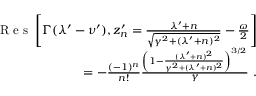Convert formula to latex. <formula><loc_0><loc_0><loc_500><loc_500>\begin{array} { r } { R e s \left [ \Gamma ( \lambda ^ { \prime } - \nu ^ { \prime } ) , z _ { n } ^ { \prime } = \frac { \lambda ^ { \prime } + n } { \sqrt { \gamma ^ { 2 } + ( \lambda ^ { \prime } + n ) ^ { 2 } } } - \frac { \omega } { 2 } \right ] } \\ { = - \frac { ( - 1 ) ^ { n } } { n ! } \frac { \left ( 1 - \frac { ( \lambda ^ { \prime } + n ) ^ { 2 } } { \gamma ^ { 2 } + ( \lambda ^ { \prime } + n ) ^ { 2 } } \right ) ^ { 3 / 2 } } { \gamma } . } \end{array}</formula> 